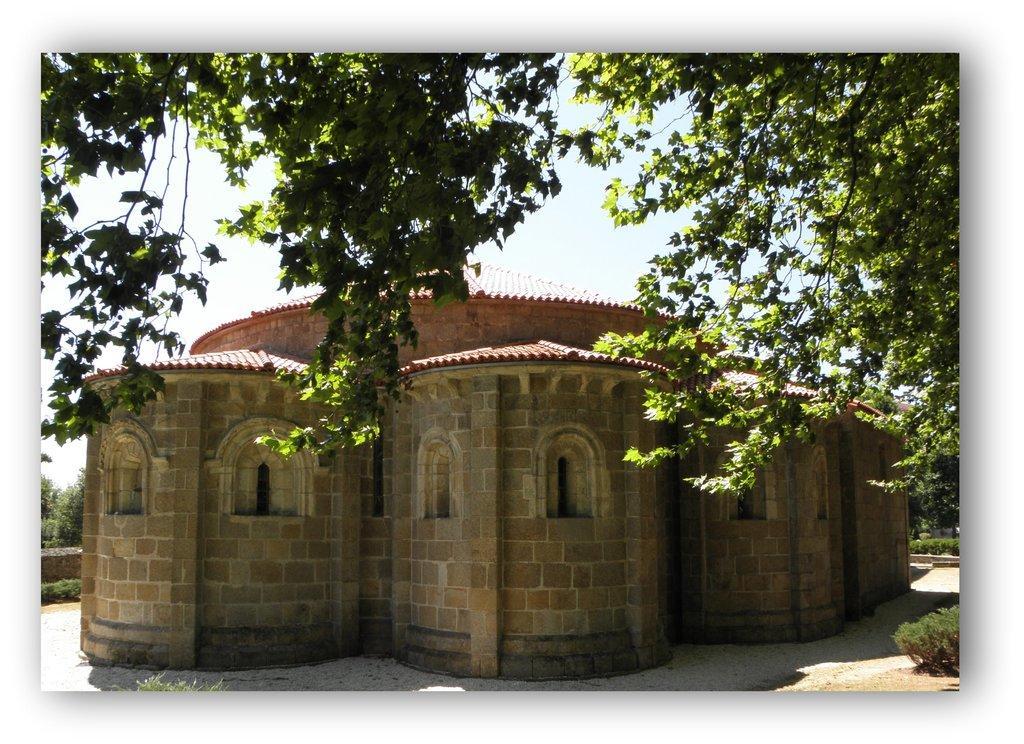Describe this image in one or two sentences. In this picture I can see a house, there are plants, trees, and in the background there is the sky. 